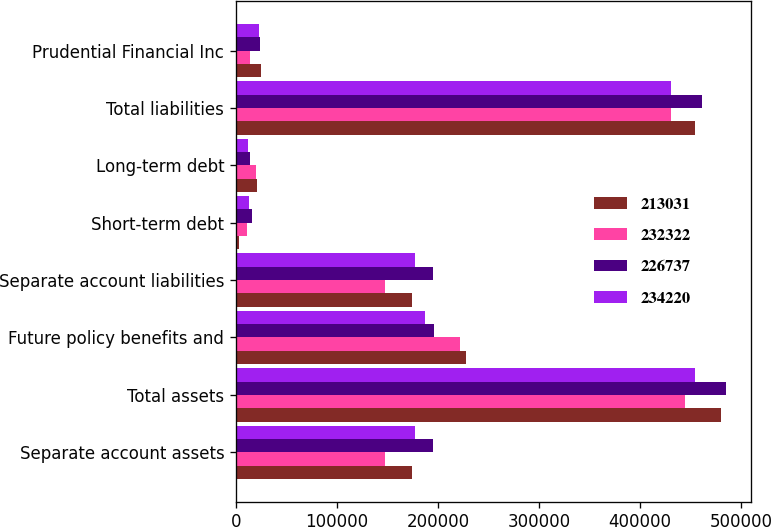Convert chart. <chart><loc_0><loc_0><loc_500><loc_500><stacked_bar_chart><ecel><fcel>Separate account assets<fcel>Total assets<fcel>Future policy benefits and<fcel>Separate account liabilities<fcel>Short-term debt<fcel>Long-term debt<fcel>Total liabilities<fcel>Prudential Financial Inc<nl><fcel>213031<fcel>174074<fcel>480203<fcel>227373<fcel>174074<fcel>3122<fcel>21037<fcel>454474<fcel>25195<nl><fcel>232322<fcel>147095<fcel>445011<fcel>221564<fcel>147095<fcel>10535<fcel>20290<fcel>431225<fcel>13435<nl><fcel>226737<fcel>195583<fcel>485813<fcel>195731<fcel>195583<fcel>15566<fcel>14101<fcel>461890<fcel>23514<nl><fcel>234220<fcel>177463<fcel>454266<fcel>187652<fcel>177463<fcel>12472<fcel>11423<fcel>431005<fcel>22932<nl></chart> 